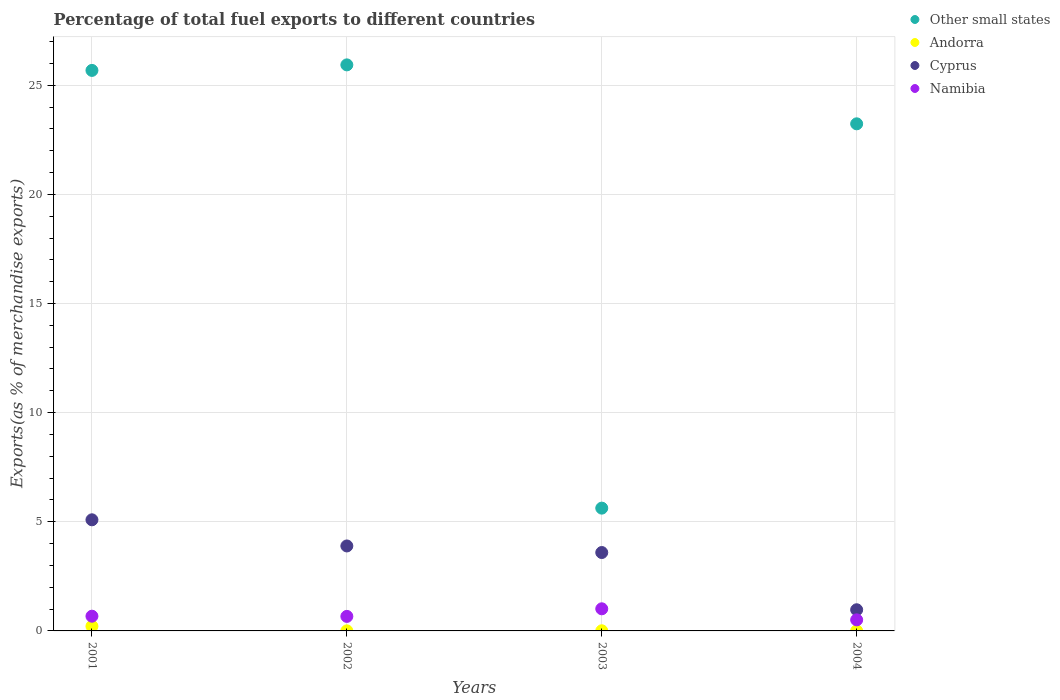What is the percentage of exports to different countries in Namibia in 2002?
Offer a very short reply. 0.67. Across all years, what is the maximum percentage of exports to different countries in Other small states?
Your response must be concise. 25.93. Across all years, what is the minimum percentage of exports to different countries in Other small states?
Keep it short and to the point. 5.63. In which year was the percentage of exports to different countries in Other small states maximum?
Provide a succinct answer. 2002. In which year was the percentage of exports to different countries in Cyprus minimum?
Offer a terse response. 2004. What is the total percentage of exports to different countries in Andorra in the graph?
Provide a succinct answer. 0.23. What is the difference between the percentage of exports to different countries in Namibia in 2001 and that in 2004?
Offer a terse response. 0.17. What is the difference between the percentage of exports to different countries in Namibia in 2004 and the percentage of exports to different countries in Andorra in 2003?
Provide a succinct answer. 0.5. What is the average percentage of exports to different countries in Namibia per year?
Offer a very short reply. 0.72. In the year 2003, what is the difference between the percentage of exports to different countries in Cyprus and percentage of exports to different countries in Andorra?
Your answer should be compact. 3.58. What is the ratio of the percentage of exports to different countries in Cyprus in 2001 to that in 2004?
Offer a terse response. 5.25. Is the difference between the percentage of exports to different countries in Cyprus in 2001 and 2002 greater than the difference between the percentage of exports to different countries in Andorra in 2001 and 2002?
Your answer should be compact. Yes. What is the difference between the highest and the second highest percentage of exports to different countries in Namibia?
Provide a succinct answer. 0.34. What is the difference between the highest and the lowest percentage of exports to different countries in Cyprus?
Provide a succinct answer. 4.12. In how many years, is the percentage of exports to different countries in Andorra greater than the average percentage of exports to different countries in Andorra taken over all years?
Your response must be concise. 1. Is it the case that in every year, the sum of the percentage of exports to different countries in Andorra and percentage of exports to different countries in Other small states  is greater than the sum of percentage of exports to different countries in Namibia and percentage of exports to different countries in Cyprus?
Your answer should be very brief. Yes. Is it the case that in every year, the sum of the percentage of exports to different countries in Namibia and percentage of exports to different countries in Andorra  is greater than the percentage of exports to different countries in Cyprus?
Ensure brevity in your answer.  No. Is the percentage of exports to different countries in Other small states strictly less than the percentage of exports to different countries in Cyprus over the years?
Offer a terse response. No. How many dotlines are there?
Keep it short and to the point. 4. What is the difference between two consecutive major ticks on the Y-axis?
Provide a succinct answer. 5. Does the graph contain any zero values?
Your answer should be compact. No. How many legend labels are there?
Your answer should be compact. 4. What is the title of the graph?
Your answer should be compact. Percentage of total fuel exports to different countries. What is the label or title of the X-axis?
Keep it short and to the point. Years. What is the label or title of the Y-axis?
Offer a very short reply. Exports(as % of merchandise exports). What is the Exports(as % of merchandise exports) of Other small states in 2001?
Provide a succinct answer. 25.68. What is the Exports(as % of merchandise exports) of Andorra in 2001?
Ensure brevity in your answer.  0.21. What is the Exports(as % of merchandise exports) in Cyprus in 2001?
Provide a short and direct response. 5.09. What is the Exports(as % of merchandise exports) in Namibia in 2001?
Make the answer very short. 0.67. What is the Exports(as % of merchandise exports) of Other small states in 2002?
Provide a succinct answer. 25.93. What is the Exports(as % of merchandise exports) of Andorra in 2002?
Your answer should be compact. 0. What is the Exports(as % of merchandise exports) in Cyprus in 2002?
Give a very brief answer. 3.89. What is the Exports(as % of merchandise exports) of Namibia in 2002?
Give a very brief answer. 0.67. What is the Exports(as % of merchandise exports) in Other small states in 2003?
Offer a very short reply. 5.63. What is the Exports(as % of merchandise exports) of Andorra in 2003?
Your answer should be very brief. 0.01. What is the Exports(as % of merchandise exports) in Cyprus in 2003?
Offer a terse response. 3.59. What is the Exports(as % of merchandise exports) in Namibia in 2003?
Your response must be concise. 1.01. What is the Exports(as % of merchandise exports) in Other small states in 2004?
Your answer should be very brief. 23.23. What is the Exports(as % of merchandise exports) in Andorra in 2004?
Give a very brief answer. 0. What is the Exports(as % of merchandise exports) of Cyprus in 2004?
Provide a short and direct response. 0.97. What is the Exports(as % of merchandise exports) in Namibia in 2004?
Provide a succinct answer. 0.51. Across all years, what is the maximum Exports(as % of merchandise exports) in Other small states?
Ensure brevity in your answer.  25.93. Across all years, what is the maximum Exports(as % of merchandise exports) in Andorra?
Your answer should be compact. 0.21. Across all years, what is the maximum Exports(as % of merchandise exports) of Cyprus?
Your answer should be very brief. 5.09. Across all years, what is the maximum Exports(as % of merchandise exports) of Namibia?
Provide a short and direct response. 1.01. Across all years, what is the minimum Exports(as % of merchandise exports) of Other small states?
Your answer should be compact. 5.63. Across all years, what is the minimum Exports(as % of merchandise exports) in Andorra?
Your response must be concise. 0. Across all years, what is the minimum Exports(as % of merchandise exports) in Cyprus?
Keep it short and to the point. 0.97. Across all years, what is the minimum Exports(as % of merchandise exports) of Namibia?
Provide a succinct answer. 0.51. What is the total Exports(as % of merchandise exports) of Other small states in the graph?
Make the answer very short. 80.47. What is the total Exports(as % of merchandise exports) in Andorra in the graph?
Provide a succinct answer. 0.23. What is the total Exports(as % of merchandise exports) in Cyprus in the graph?
Ensure brevity in your answer.  13.54. What is the total Exports(as % of merchandise exports) of Namibia in the graph?
Offer a very short reply. 2.86. What is the difference between the Exports(as % of merchandise exports) in Other small states in 2001 and that in 2002?
Provide a succinct answer. -0.25. What is the difference between the Exports(as % of merchandise exports) in Andorra in 2001 and that in 2002?
Your response must be concise. 0.21. What is the difference between the Exports(as % of merchandise exports) of Cyprus in 2001 and that in 2002?
Ensure brevity in your answer.  1.2. What is the difference between the Exports(as % of merchandise exports) of Namibia in 2001 and that in 2002?
Your response must be concise. 0.01. What is the difference between the Exports(as % of merchandise exports) of Other small states in 2001 and that in 2003?
Keep it short and to the point. 20.05. What is the difference between the Exports(as % of merchandise exports) of Andorra in 2001 and that in 2003?
Offer a terse response. 0.21. What is the difference between the Exports(as % of merchandise exports) of Cyprus in 2001 and that in 2003?
Offer a very short reply. 1.5. What is the difference between the Exports(as % of merchandise exports) of Namibia in 2001 and that in 2003?
Give a very brief answer. -0.34. What is the difference between the Exports(as % of merchandise exports) of Other small states in 2001 and that in 2004?
Give a very brief answer. 2.45. What is the difference between the Exports(as % of merchandise exports) of Andorra in 2001 and that in 2004?
Make the answer very short. 0.21. What is the difference between the Exports(as % of merchandise exports) in Cyprus in 2001 and that in 2004?
Make the answer very short. 4.12. What is the difference between the Exports(as % of merchandise exports) of Namibia in 2001 and that in 2004?
Your answer should be compact. 0.17. What is the difference between the Exports(as % of merchandise exports) of Other small states in 2002 and that in 2003?
Provide a succinct answer. 20.31. What is the difference between the Exports(as % of merchandise exports) in Andorra in 2002 and that in 2003?
Keep it short and to the point. -0. What is the difference between the Exports(as % of merchandise exports) of Cyprus in 2002 and that in 2003?
Your response must be concise. 0.3. What is the difference between the Exports(as % of merchandise exports) in Namibia in 2002 and that in 2003?
Offer a terse response. -0.35. What is the difference between the Exports(as % of merchandise exports) in Other small states in 2002 and that in 2004?
Your response must be concise. 2.7. What is the difference between the Exports(as % of merchandise exports) in Andorra in 2002 and that in 2004?
Keep it short and to the point. 0. What is the difference between the Exports(as % of merchandise exports) of Cyprus in 2002 and that in 2004?
Offer a terse response. 2.92. What is the difference between the Exports(as % of merchandise exports) of Namibia in 2002 and that in 2004?
Your answer should be very brief. 0.16. What is the difference between the Exports(as % of merchandise exports) in Other small states in 2003 and that in 2004?
Your answer should be very brief. -17.61. What is the difference between the Exports(as % of merchandise exports) of Andorra in 2003 and that in 2004?
Your answer should be compact. 0. What is the difference between the Exports(as % of merchandise exports) in Cyprus in 2003 and that in 2004?
Make the answer very short. 2.62. What is the difference between the Exports(as % of merchandise exports) in Namibia in 2003 and that in 2004?
Keep it short and to the point. 0.51. What is the difference between the Exports(as % of merchandise exports) in Other small states in 2001 and the Exports(as % of merchandise exports) in Andorra in 2002?
Ensure brevity in your answer.  25.68. What is the difference between the Exports(as % of merchandise exports) in Other small states in 2001 and the Exports(as % of merchandise exports) in Cyprus in 2002?
Ensure brevity in your answer.  21.79. What is the difference between the Exports(as % of merchandise exports) of Other small states in 2001 and the Exports(as % of merchandise exports) of Namibia in 2002?
Keep it short and to the point. 25.01. What is the difference between the Exports(as % of merchandise exports) of Andorra in 2001 and the Exports(as % of merchandise exports) of Cyprus in 2002?
Provide a short and direct response. -3.68. What is the difference between the Exports(as % of merchandise exports) in Andorra in 2001 and the Exports(as % of merchandise exports) in Namibia in 2002?
Keep it short and to the point. -0.45. What is the difference between the Exports(as % of merchandise exports) of Cyprus in 2001 and the Exports(as % of merchandise exports) of Namibia in 2002?
Make the answer very short. 4.43. What is the difference between the Exports(as % of merchandise exports) in Other small states in 2001 and the Exports(as % of merchandise exports) in Andorra in 2003?
Your answer should be compact. 25.67. What is the difference between the Exports(as % of merchandise exports) in Other small states in 2001 and the Exports(as % of merchandise exports) in Cyprus in 2003?
Ensure brevity in your answer.  22.09. What is the difference between the Exports(as % of merchandise exports) of Other small states in 2001 and the Exports(as % of merchandise exports) of Namibia in 2003?
Provide a short and direct response. 24.67. What is the difference between the Exports(as % of merchandise exports) of Andorra in 2001 and the Exports(as % of merchandise exports) of Cyprus in 2003?
Keep it short and to the point. -3.38. What is the difference between the Exports(as % of merchandise exports) in Andorra in 2001 and the Exports(as % of merchandise exports) in Namibia in 2003?
Provide a short and direct response. -0.8. What is the difference between the Exports(as % of merchandise exports) in Cyprus in 2001 and the Exports(as % of merchandise exports) in Namibia in 2003?
Your answer should be very brief. 4.08. What is the difference between the Exports(as % of merchandise exports) of Other small states in 2001 and the Exports(as % of merchandise exports) of Andorra in 2004?
Ensure brevity in your answer.  25.68. What is the difference between the Exports(as % of merchandise exports) in Other small states in 2001 and the Exports(as % of merchandise exports) in Cyprus in 2004?
Provide a succinct answer. 24.71. What is the difference between the Exports(as % of merchandise exports) in Other small states in 2001 and the Exports(as % of merchandise exports) in Namibia in 2004?
Make the answer very short. 25.17. What is the difference between the Exports(as % of merchandise exports) in Andorra in 2001 and the Exports(as % of merchandise exports) in Cyprus in 2004?
Your response must be concise. -0.76. What is the difference between the Exports(as % of merchandise exports) of Andorra in 2001 and the Exports(as % of merchandise exports) of Namibia in 2004?
Give a very brief answer. -0.29. What is the difference between the Exports(as % of merchandise exports) in Cyprus in 2001 and the Exports(as % of merchandise exports) in Namibia in 2004?
Your answer should be compact. 4.58. What is the difference between the Exports(as % of merchandise exports) in Other small states in 2002 and the Exports(as % of merchandise exports) in Andorra in 2003?
Your answer should be very brief. 25.93. What is the difference between the Exports(as % of merchandise exports) in Other small states in 2002 and the Exports(as % of merchandise exports) in Cyprus in 2003?
Offer a very short reply. 22.34. What is the difference between the Exports(as % of merchandise exports) in Other small states in 2002 and the Exports(as % of merchandise exports) in Namibia in 2003?
Your response must be concise. 24.92. What is the difference between the Exports(as % of merchandise exports) in Andorra in 2002 and the Exports(as % of merchandise exports) in Cyprus in 2003?
Your answer should be very brief. -3.59. What is the difference between the Exports(as % of merchandise exports) of Andorra in 2002 and the Exports(as % of merchandise exports) of Namibia in 2003?
Your answer should be compact. -1.01. What is the difference between the Exports(as % of merchandise exports) in Cyprus in 2002 and the Exports(as % of merchandise exports) in Namibia in 2003?
Your answer should be very brief. 2.88. What is the difference between the Exports(as % of merchandise exports) in Other small states in 2002 and the Exports(as % of merchandise exports) in Andorra in 2004?
Your answer should be compact. 25.93. What is the difference between the Exports(as % of merchandise exports) of Other small states in 2002 and the Exports(as % of merchandise exports) of Cyprus in 2004?
Make the answer very short. 24.96. What is the difference between the Exports(as % of merchandise exports) of Other small states in 2002 and the Exports(as % of merchandise exports) of Namibia in 2004?
Your answer should be very brief. 25.42. What is the difference between the Exports(as % of merchandise exports) in Andorra in 2002 and the Exports(as % of merchandise exports) in Cyprus in 2004?
Your answer should be very brief. -0.97. What is the difference between the Exports(as % of merchandise exports) in Andorra in 2002 and the Exports(as % of merchandise exports) in Namibia in 2004?
Provide a short and direct response. -0.5. What is the difference between the Exports(as % of merchandise exports) in Cyprus in 2002 and the Exports(as % of merchandise exports) in Namibia in 2004?
Provide a short and direct response. 3.39. What is the difference between the Exports(as % of merchandise exports) of Other small states in 2003 and the Exports(as % of merchandise exports) of Andorra in 2004?
Provide a succinct answer. 5.62. What is the difference between the Exports(as % of merchandise exports) of Other small states in 2003 and the Exports(as % of merchandise exports) of Cyprus in 2004?
Provide a short and direct response. 4.66. What is the difference between the Exports(as % of merchandise exports) in Other small states in 2003 and the Exports(as % of merchandise exports) in Namibia in 2004?
Make the answer very short. 5.12. What is the difference between the Exports(as % of merchandise exports) of Andorra in 2003 and the Exports(as % of merchandise exports) of Cyprus in 2004?
Offer a very short reply. -0.96. What is the difference between the Exports(as % of merchandise exports) in Andorra in 2003 and the Exports(as % of merchandise exports) in Namibia in 2004?
Provide a short and direct response. -0.5. What is the difference between the Exports(as % of merchandise exports) of Cyprus in 2003 and the Exports(as % of merchandise exports) of Namibia in 2004?
Keep it short and to the point. 3.08. What is the average Exports(as % of merchandise exports) of Other small states per year?
Ensure brevity in your answer.  20.12. What is the average Exports(as % of merchandise exports) in Andorra per year?
Your response must be concise. 0.06. What is the average Exports(as % of merchandise exports) in Cyprus per year?
Offer a terse response. 3.39. What is the average Exports(as % of merchandise exports) in Namibia per year?
Offer a terse response. 0.72. In the year 2001, what is the difference between the Exports(as % of merchandise exports) in Other small states and Exports(as % of merchandise exports) in Andorra?
Give a very brief answer. 25.47. In the year 2001, what is the difference between the Exports(as % of merchandise exports) of Other small states and Exports(as % of merchandise exports) of Cyprus?
Your answer should be very brief. 20.59. In the year 2001, what is the difference between the Exports(as % of merchandise exports) of Other small states and Exports(as % of merchandise exports) of Namibia?
Your response must be concise. 25. In the year 2001, what is the difference between the Exports(as % of merchandise exports) of Andorra and Exports(as % of merchandise exports) of Cyprus?
Offer a very short reply. -4.88. In the year 2001, what is the difference between the Exports(as % of merchandise exports) in Andorra and Exports(as % of merchandise exports) in Namibia?
Provide a succinct answer. -0.46. In the year 2001, what is the difference between the Exports(as % of merchandise exports) in Cyprus and Exports(as % of merchandise exports) in Namibia?
Provide a short and direct response. 4.42. In the year 2002, what is the difference between the Exports(as % of merchandise exports) in Other small states and Exports(as % of merchandise exports) in Andorra?
Ensure brevity in your answer.  25.93. In the year 2002, what is the difference between the Exports(as % of merchandise exports) in Other small states and Exports(as % of merchandise exports) in Cyprus?
Your response must be concise. 22.04. In the year 2002, what is the difference between the Exports(as % of merchandise exports) of Other small states and Exports(as % of merchandise exports) of Namibia?
Your answer should be compact. 25.27. In the year 2002, what is the difference between the Exports(as % of merchandise exports) of Andorra and Exports(as % of merchandise exports) of Cyprus?
Offer a very short reply. -3.89. In the year 2002, what is the difference between the Exports(as % of merchandise exports) of Andorra and Exports(as % of merchandise exports) of Namibia?
Provide a succinct answer. -0.66. In the year 2002, what is the difference between the Exports(as % of merchandise exports) of Cyprus and Exports(as % of merchandise exports) of Namibia?
Offer a terse response. 3.23. In the year 2003, what is the difference between the Exports(as % of merchandise exports) of Other small states and Exports(as % of merchandise exports) of Andorra?
Make the answer very short. 5.62. In the year 2003, what is the difference between the Exports(as % of merchandise exports) of Other small states and Exports(as % of merchandise exports) of Cyprus?
Your answer should be compact. 2.03. In the year 2003, what is the difference between the Exports(as % of merchandise exports) of Other small states and Exports(as % of merchandise exports) of Namibia?
Offer a terse response. 4.61. In the year 2003, what is the difference between the Exports(as % of merchandise exports) of Andorra and Exports(as % of merchandise exports) of Cyprus?
Offer a terse response. -3.58. In the year 2003, what is the difference between the Exports(as % of merchandise exports) in Andorra and Exports(as % of merchandise exports) in Namibia?
Provide a succinct answer. -1.01. In the year 2003, what is the difference between the Exports(as % of merchandise exports) of Cyprus and Exports(as % of merchandise exports) of Namibia?
Ensure brevity in your answer.  2.58. In the year 2004, what is the difference between the Exports(as % of merchandise exports) of Other small states and Exports(as % of merchandise exports) of Andorra?
Keep it short and to the point. 23.23. In the year 2004, what is the difference between the Exports(as % of merchandise exports) in Other small states and Exports(as % of merchandise exports) in Cyprus?
Make the answer very short. 22.26. In the year 2004, what is the difference between the Exports(as % of merchandise exports) of Other small states and Exports(as % of merchandise exports) of Namibia?
Provide a short and direct response. 22.72. In the year 2004, what is the difference between the Exports(as % of merchandise exports) of Andorra and Exports(as % of merchandise exports) of Cyprus?
Provide a short and direct response. -0.97. In the year 2004, what is the difference between the Exports(as % of merchandise exports) in Andorra and Exports(as % of merchandise exports) in Namibia?
Your answer should be very brief. -0.51. In the year 2004, what is the difference between the Exports(as % of merchandise exports) of Cyprus and Exports(as % of merchandise exports) of Namibia?
Your answer should be compact. 0.46. What is the ratio of the Exports(as % of merchandise exports) of Other small states in 2001 to that in 2002?
Your answer should be compact. 0.99. What is the ratio of the Exports(as % of merchandise exports) in Andorra in 2001 to that in 2002?
Your answer should be compact. 62.48. What is the ratio of the Exports(as % of merchandise exports) in Cyprus in 2001 to that in 2002?
Your response must be concise. 1.31. What is the ratio of the Exports(as % of merchandise exports) of Namibia in 2001 to that in 2002?
Your answer should be very brief. 1.01. What is the ratio of the Exports(as % of merchandise exports) in Other small states in 2001 to that in 2003?
Offer a terse response. 4.56. What is the ratio of the Exports(as % of merchandise exports) in Andorra in 2001 to that in 2003?
Your answer should be very brief. 32.25. What is the ratio of the Exports(as % of merchandise exports) in Cyprus in 2001 to that in 2003?
Provide a short and direct response. 1.42. What is the ratio of the Exports(as % of merchandise exports) of Namibia in 2001 to that in 2003?
Ensure brevity in your answer.  0.67. What is the ratio of the Exports(as % of merchandise exports) in Other small states in 2001 to that in 2004?
Keep it short and to the point. 1.11. What is the ratio of the Exports(as % of merchandise exports) in Andorra in 2001 to that in 2004?
Your response must be concise. 107.62. What is the ratio of the Exports(as % of merchandise exports) in Cyprus in 2001 to that in 2004?
Offer a very short reply. 5.25. What is the ratio of the Exports(as % of merchandise exports) in Namibia in 2001 to that in 2004?
Give a very brief answer. 1.33. What is the ratio of the Exports(as % of merchandise exports) of Other small states in 2002 to that in 2003?
Ensure brevity in your answer.  4.61. What is the ratio of the Exports(as % of merchandise exports) of Andorra in 2002 to that in 2003?
Provide a succinct answer. 0.52. What is the ratio of the Exports(as % of merchandise exports) in Cyprus in 2002 to that in 2003?
Your response must be concise. 1.08. What is the ratio of the Exports(as % of merchandise exports) of Namibia in 2002 to that in 2003?
Your answer should be very brief. 0.66. What is the ratio of the Exports(as % of merchandise exports) in Other small states in 2002 to that in 2004?
Give a very brief answer. 1.12. What is the ratio of the Exports(as % of merchandise exports) in Andorra in 2002 to that in 2004?
Your answer should be very brief. 1.72. What is the ratio of the Exports(as % of merchandise exports) of Cyprus in 2002 to that in 2004?
Provide a short and direct response. 4.01. What is the ratio of the Exports(as % of merchandise exports) in Namibia in 2002 to that in 2004?
Offer a very short reply. 1.31. What is the ratio of the Exports(as % of merchandise exports) of Other small states in 2003 to that in 2004?
Provide a short and direct response. 0.24. What is the ratio of the Exports(as % of merchandise exports) of Andorra in 2003 to that in 2004?
Your response must be concise. 3.34. What is the ratio of the Exports(as % of merchandise exports) in Cyprus in 2003 to that in 2004?
Offer a terse response. 3.7. What is the ratio of the Exports(as % of merchandise exports) of Namibia in 2003 to that in 2004?
Give a very brief answer. 2. What is the difference between the highest and the second highest Exports(as % of merchandise exports) of Other small states?
Provide a succinct answer. 0.25. What is the difference between the highest and the second highest Exports(as % of merchandise exports) of Andorra?
Give a very brief answer. 0.21. What is the difference between the highest and the second highest Exports(as % of merchandise exports) of Cyprus?
Give a very brief answer. 1.2. What is the difference between the highest and the second highest Exports(as % of merchandise exports) of Namibia?
Keep it short and to the point. 0.34. What is the difference between the highest and the lowest Exports(as % of merchandise exports) of Other small states?
Give a very brief answer. 20.31. What is the difference between the highest and the lowest Exports(as % of merchandise exports) in Andorra?
Offer a terse response. 0.21. What is the difference between the highest and the lowest Exports(as % of merchandise exports) in Cyprus?
Make the answer very short. 4.12. What is the difference between the highest and the lowest Exports(as % of merchandise exports) of Namibia?
Ensure brevity in your answer.  0.51. 